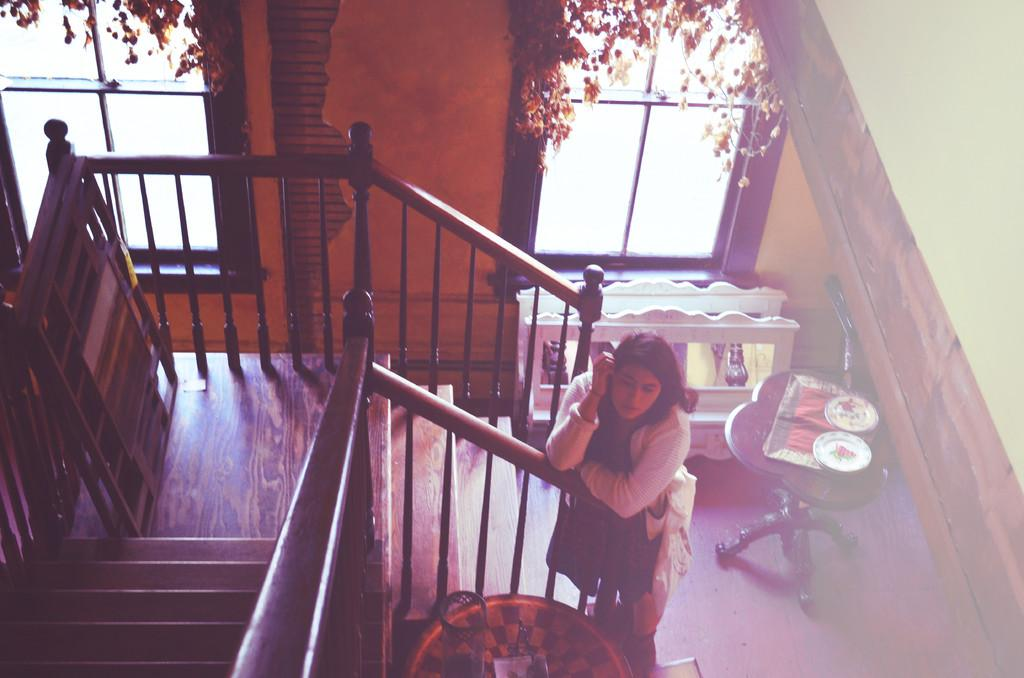What is the lady in the image doing? The lady is standing beside the stairs. What can be seen in the background of the image? There are many objects visible at the back. What architectural feature is present in the middle of the wall? There are windows in the middle of the wall. What is the manager's role in the territory depicted in the image? There is no mention of a manager or territory in the image, so it is not possible to answer that question. 